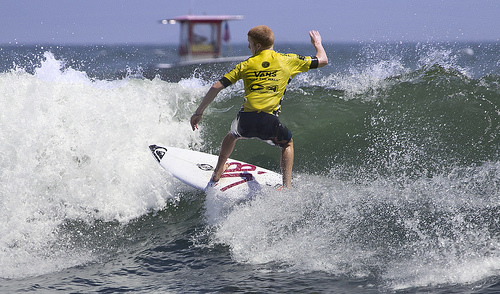<image>
Is the surfboard in the boat? No. The surfboard is not contained within the boat. These objects have a different spatial relationship. 